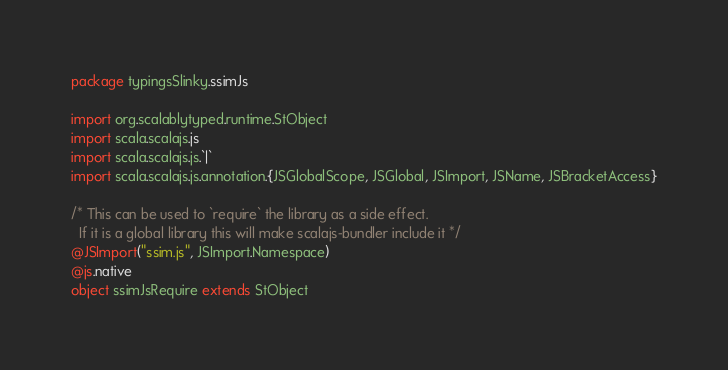<code> <loc_0><loc_0><loc_500><loc_500><_Scala_>package typingsSlinky.ssimJs

import org.scalablytyped.runtime.StObject
import scala.scalajs.js
import scala.scalajs.js.`|`
import scala.scalajs.js.annotation.{JSGlobalScope, JSGlobal, JSImport, JSName, JSBracketAccess}

/* This can be used to `require` the library as a side effect.
  If it is a global library this will make scalajs-bundler include it */
@JSImport("ssim.js", JSImport.Namespace)
@js.native
object ssimJsRequire extends StObject
</code> 